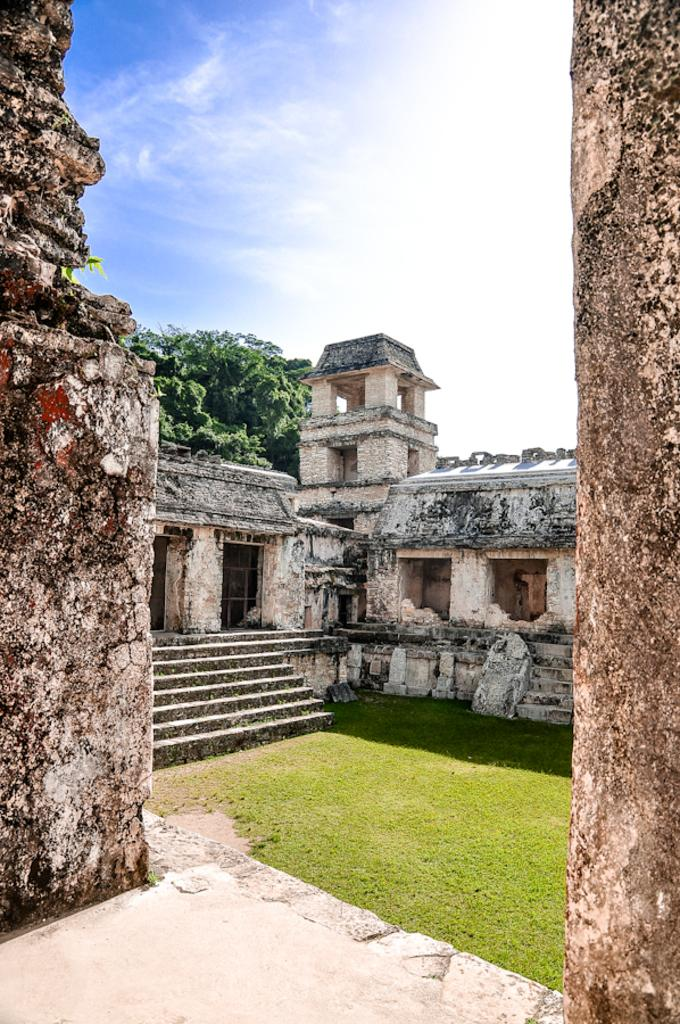What is: What type of structure is present in the image? There is a building in the image. What feature of the building is mentioned in the facts? The building has stairs. What type of vegetation can be seen in the image? There is grass in the image. What is visible in the background of the image? There is a tree in the background of the image. What is visible at the top of the image? The sky is visible at the top of the image. Can you tell me what the goose is reading while kissing the tree in the image? There is no goose or any reading or kissing activity present in the image. 